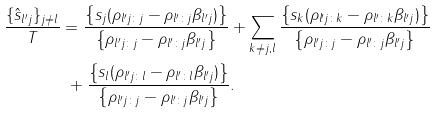<formula> <loc_0><loc_0><loc_500><loc_500>\frac { \{ \hat { s } _ { l ^ { \prime } j } \} _ { j \neq l } } { T } & = \frac { \left \{ s _ { j } ( \rho _ { l ^ { \prime } j \colon j } - \rho _ { l ^ { \prime } \colon j } \beta _ { l ^ { \prime } j } ) \right \} } { \left \{ \rho _ { l ^ { \prime } j \colon j } - \rho _ { l ^ { \prime } \colon j } \beta _ { l ^ { \prime } j } \right \} } + \sum _ { k \neq j , l } \frac { \left \{ s _ { k } ( \rho _ { l ^ { \prime } j \colon k } - \rho _ { l ^ { \prime } \colon k } \beta _ { l ^ { \prime } j } ) \right \} } { \left \{ \rho _ { l ^ { \prime } j \colon j } - \rho _ { l ^ { \prime } \colon j } \beta _ { l ^ { \prime } j } \right \} } \\ & \ + \frac { \left \{ s _ { l } ( \rho _ { l ^ { \prime } j \colon l } - \rho _ { l ^ { \prime } \colon l } \beta _ { l ^ { \prime } j } ) \right \} } { \left \{ \rho _ { l ^ { \prime } j \colon j } - \rho _ { l ^ { \prime } \colon j } \beta _ { l ^ { \prime } j } \right \} } .</formula> 